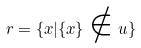Convert formula to latex. <formula><loc_0><loc_0><loc_500><loc_500>r = \{ x | \{ x \} \notin u \}</formula> 